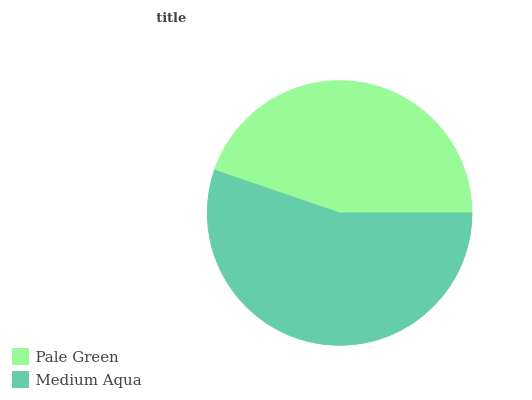Is Pale Green the minimum?
Answer yes or no. Yes. Is Medium Aqua the maximum?
Answer yes or no. Yes. Is Medium Aqua the minimum?
Answer yes or no. No. Is Medium Aqua greater than Pale Green?
Answer yes or no. Yes. Is Pale Green less than Medium Aqua?
Answer yes or no. Yes. Is Pale Green greater than Medium Aqua?
Answer yes or no. No. Is Medium Aqua less than Pale Green?
Answer yes or no. No. Is Medium Aqua the high median?
Answer yes or no. Yes. Is Pale Green the low median?
Answer yes or no. Yes. Is Pale Green the high median?
Answer yes or no. No. Is Medium Aqua the low median?
Answer yes or no. No. 